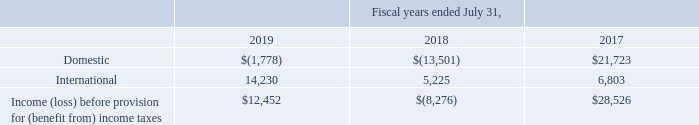9. Income Taxes
On December 22, 2017, the Tax Act was enacted into law, which made changes to U.S. tax law, including, but not limited to: (1) reducing the U.S. Federal corporate income tax rate from 35% to 21%; (2) requiring companies to pay a one-time transition tax on certain unrepatriated earnings of foreign subsidiaries; (3) generally eliminating U.S. Federal corporate income taxes on dividends from foreign subsidiaries; (4) capitalizing R&D expenses which are amortized over five to 15 years; and (5) other changes to how foreign and domestic earnings are taxed.
The Tax Act includes a provision to tax global intangible low-taxed income (“GILTI”) of foreign subsidiaries and a base erosion anti-abuse tax (“BEAT”) measure that taxes certain payments between a U.S. corporation and its foreign subsidiaries. These provisions of the Tax Act were effective for the Company beginning August 1, 2018 and had no impact on the tax benefit for the year ended July 31, 2019.
Under U.S. GAAP, the Company can make an accounting policy election to either treat taxes due on the GILTI inclusion as a current period expense or factor such amounts into its measurement of deferred taxes. The Company has elected the current period expense method. The Company has finalized its assessment of the transitional impacts of the Tax Act.
In December 2018, the IRS issued proposed regulations related to the BEAT tax, which the Company is in the process of evaluating. If the proposed BEAT regulations are finalized in their current form, the impact may be material to the tax provision in the quarter of enactment.
The U.S. Treasury Department, the Internal Revenue Service (“IRS”), and other standard-setting bodies will continue to interpret or issue guidance on how provisions of the Tax Act will be applied or otherwise administered. The Company continues to obtain, analyze, and interpret guidance as it is issued and will revise its estimates as additional information becomes available.
Any legislative changes, including any other new or proposed U.S. Department of the Treasury regulations that have yet to be issued, may result in income tax adjustments, which could be material to our provision for income taxes and effective tax rate in the period any such changes are enacted. The Company’s income (loss) before provision for (benefit from) income taxes for the years ended July 31, 2019, 2018 and 2017 is as follows (in thousands):
What was the international income (loss) before provision for (benefit from) income taxes in 2019, 2018 and 2017 respectively?
Answer scale should be: thousand. 14,230, 5,225, 6,803. What was the Domestic income (loss) before provision for (benefit from) income taxes in 2019, 2018 and 2017 respectively?
Answer scale should be: thousand. $(1,778), $(13,501), $21,723. What was the total Income (loss) before provision for (benefit from) income taxes in 2019?
Answer scale should be: thousand. $12,452. In which year was International income (loss) before provision for (benefit from) income taxes less than 10,000 thousand? Locate and analyze international in row 4
answer: 2018, 2017. What was the average Domestic income (loss) before provision for (benefit from) income taxes for 2019, 2018 and 2017?
Answer scale should be: thousand. (-1,778 - 13,501 + 21,723) / 3
Answer: 2148. What is the change in Income (loss) before provision for (benefit from) income taxes between 2017 and 2019?
Answer scale should be: thousand. 12,452 - 28,526
Answer: -16074. 